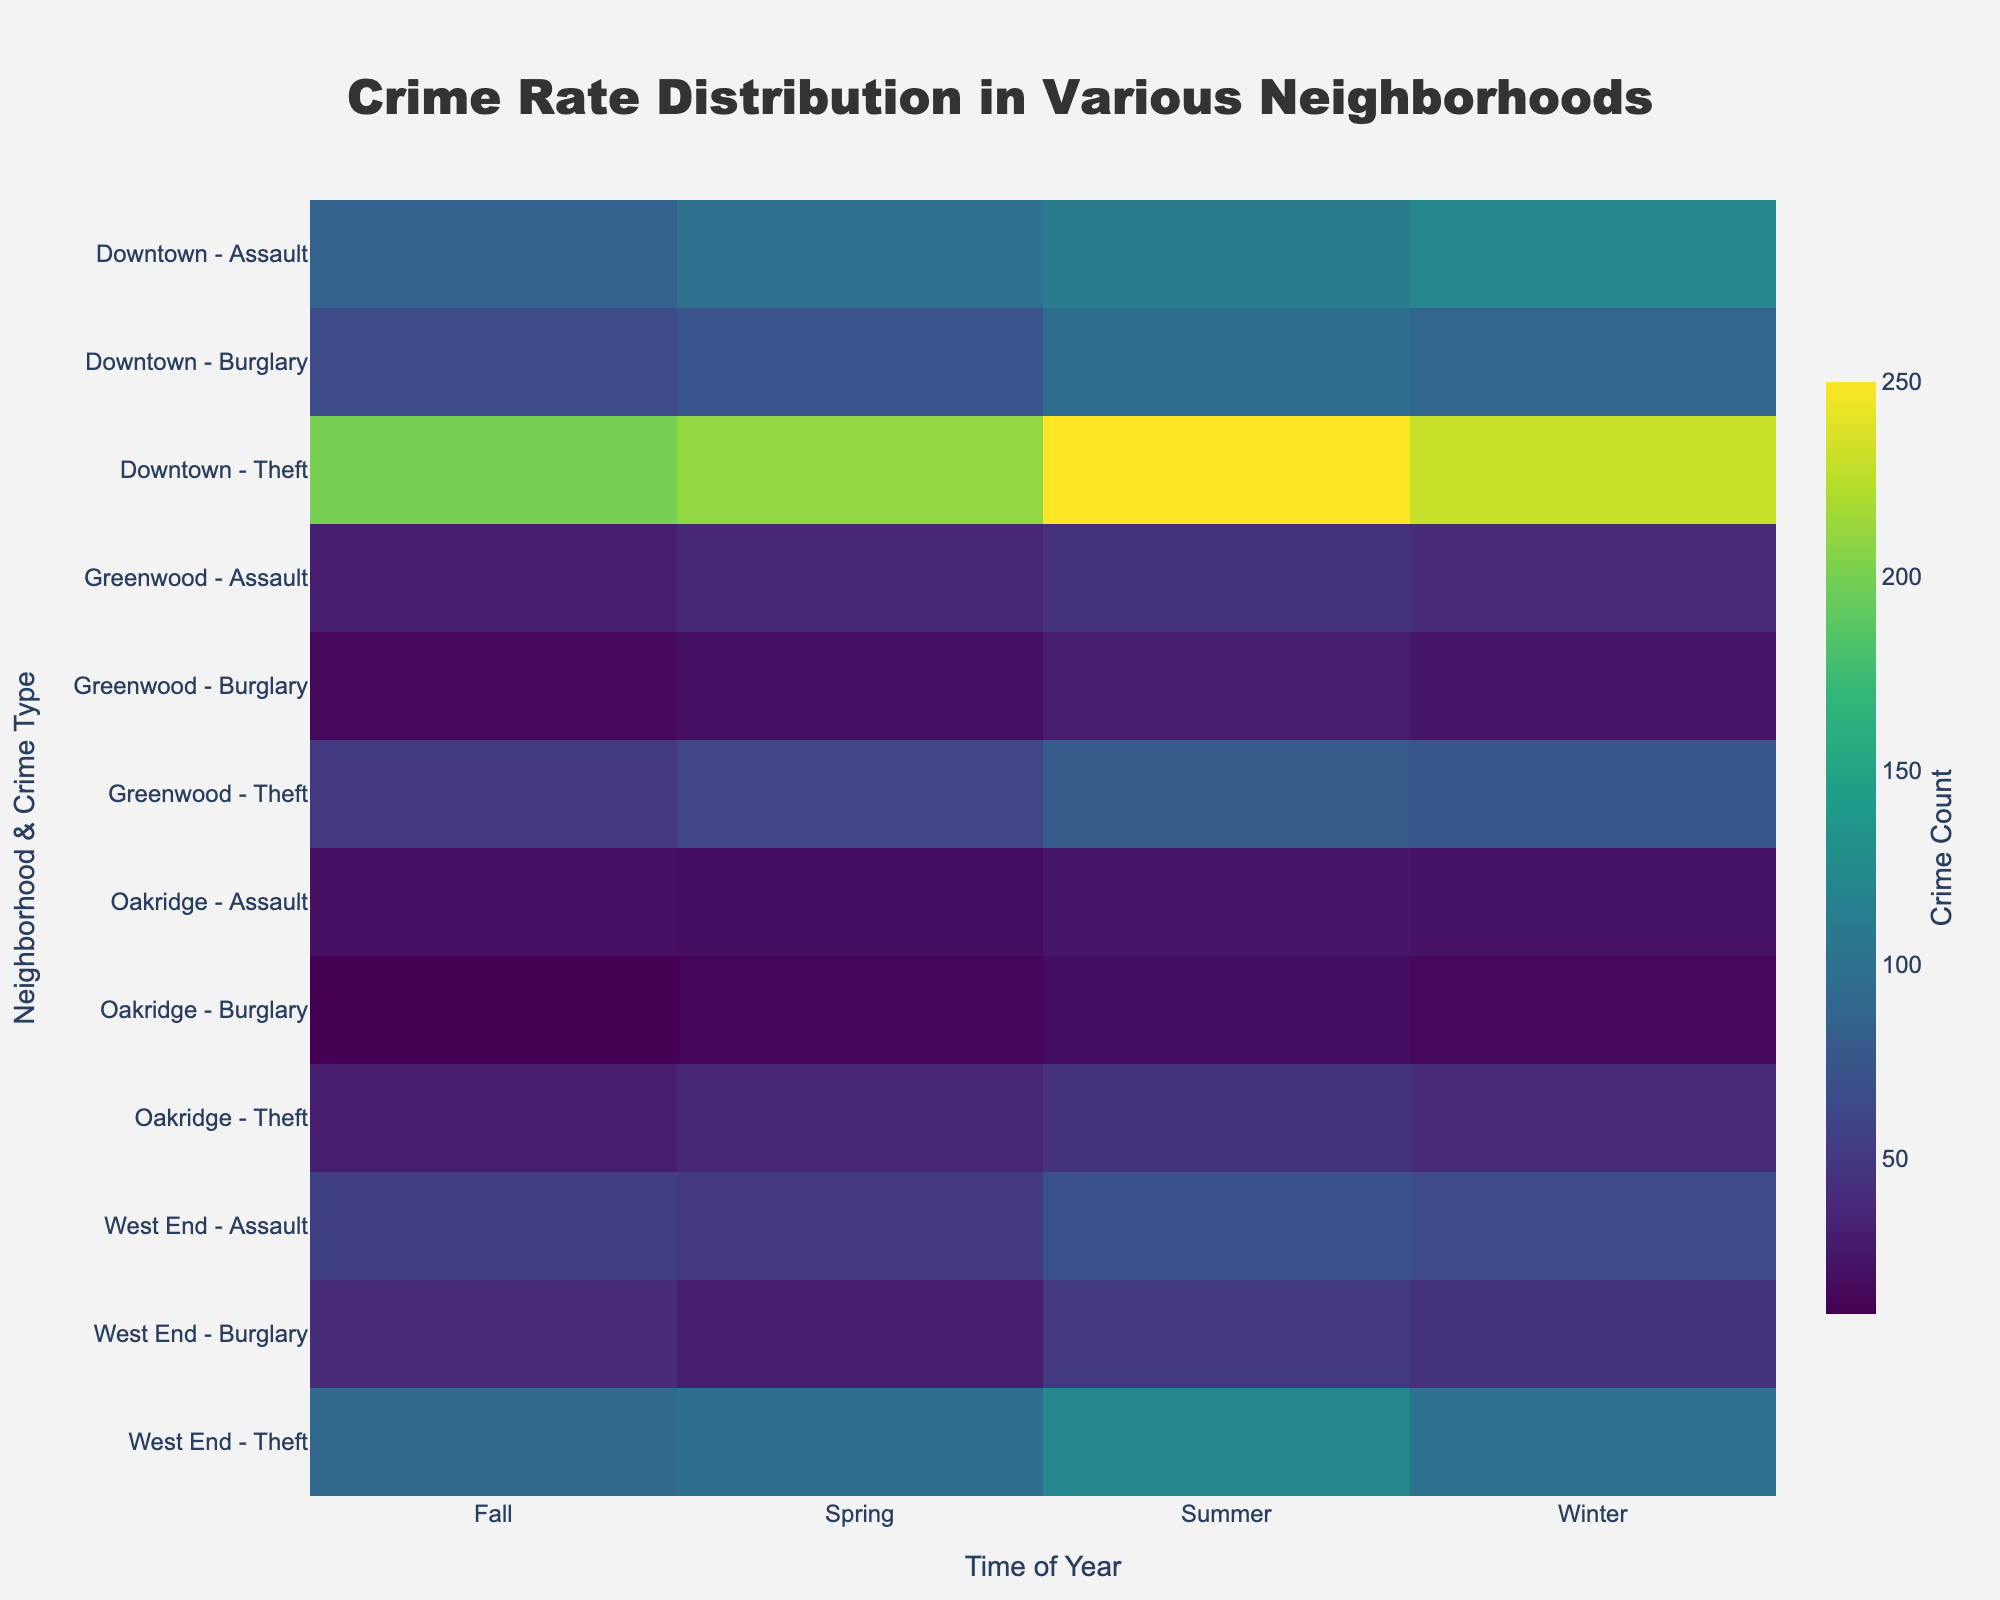What is the title of the heatmap? The title of the heatmap is usually displayed at the top center of the figure. In this figure, it is clearly stated within the provided title formatting steps.
Answer: Crime Rate Distribution in Various Neighborhoods Which neighborhood and crime type has the highest count in the Winter season? To determine which neighborhood and crime type has the highest count during Winter, look for the darkest color in the column corresponding to Winter. From the data, 'Downtown - Theft' has the highest count with a value of 230.
Answer: Downtown - Theft What is the pattern of theft crime rate change in Downtown across the seasons? Analyze the columns for Downtown and the row related to Theft. The figures are Winter: 230, Spring: 210, Summer: 250, Fall: 200. Noting the trend, the crime count is highest in Summer and lowest in Fall.
Answer: Winter: 230, Spring: 210, Summer: 250, Fall: 200 Which neighborhood has the lowest number of burglary crimes in Fall and what is the count? To identify this, locate the column for Fall and find the lightest color for burglary type. Greenwood has the lowest burglary count in Fall, with a value of 15.
Answer: Greenwood, 15 Compare the total crime count of Assault in West End with Greenwood in Summer. Sum the crime counts for Assault in West End (70) and Greenwood (45) during the Summer. Comparing the values, West End has more Assault crimes than Greenwood by 25.
Answer: West End: 70, Greenwood: 45, Difference: 25 Do all neighborhoods have a peak in theft crime rate in Summer? Examine the color intensities for theft across all neighborhoods in Summer. Downtown, West End, and Greenwood show high values, while Oakridge has a significantly lower but still the highest in the year. Thus, all neighborhoods peak in theft during Summer.
Answer: Yes What is the median crime count for 'Assault in Oakridge' for all seasons? The values for 'Assault in Oakridge' are: Winter: 22, Spring: 18, Summer: 25, Fall: 20. Sorting these gives 18, 20, 22, 25. The middle values (20 and 22) average to a median of 21.
Answer: 21 Which particular crime and season sees the lowest count among all neighborhoods and types? Look across all the cells, the lightest color indicates the lowest count. 'Oakridge - Burglary in Fall' has the lowest count with a value of 10.
Answer: Oakridge - Burglary in Fall, 10 